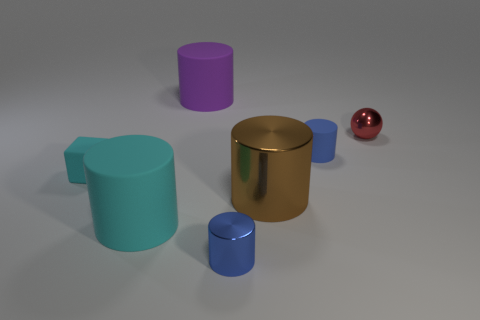There is a big rubber thing that is to the left of the big purple cylinder; does it have the same color as the rubber block?
Offer a very short reply. Yes. There is another tiny cylinder that is the same color as the small rubber cylinder; what material is it?
Give a very brief answer. Metal. Is there a matte object that has the same color as the small rubber cube?
Your answer should be very brief. Yes. How many cyan cylinders are the same material as the cyan cube?
Ensure brevity in your answer.  1. Is the number of tiny cyan blocks behind the big purple rubber cylinder less than the number of gray rubber spheres?
Give a very brief answer. No. Is there a tiny shiny cylinder that is right of the small metallic object in front of the large cyan rubber thing?
Provide a succinct answer. No. Is there anything else that is the same shape as the tiny cyan thing?
Make the answer very short. No. Do the brown cylinder and the purple matte cylinder have the same size?
Your answer should be compact. Yes. What is the material of the large object that is right of the tiny metal object that is on the left side of the tiny metallic thing that is behind the small cyan cube?
Provide a short and direct response. Metal. Is the number of tiny blue metallic cylinders that are behind the cyan matte block the same as the number of big brown balls?
Offer a terse response. Yes. 